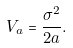<formula> <loc_0><loc_0><loc_500><loc_500>V _ { a } = \frac { \sigma ^ { 2 } } { 2 a } .</formula> 